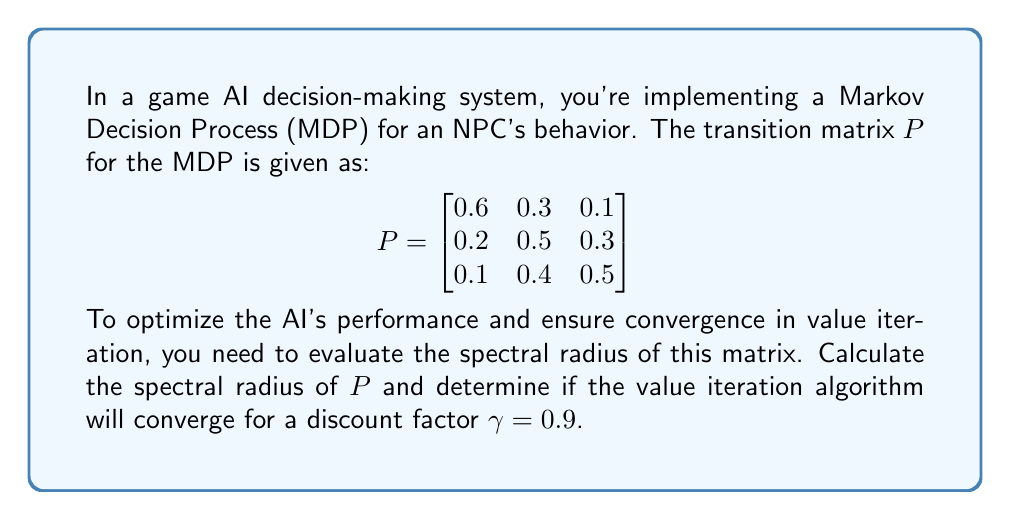Help me with this question. To solve this problem, we'll follow these steps:

1) The spectral radius of a matrix is the largest absolute value of its eigenvalues.

2) To find the eigenvalues, we need to solve the characteristic equation:
   $$\det(P - \lambda I) = 0$$

3) Expanding the determinant:
   $$\begin{vmatrix}
   0.6-\lambda & 0.3 & 0.1 \\
   0.2 & 0.5-\lambda & 0.3 \\
   0.1 & 0.4 & 0.5-\lambda
   \end{vmatrix} = 0$$

4) This gives us the characteristic polynomial:
   $$-\lambda^3 + 1.6\lambda^2 - 0.71\lambda + 0.088 = 0$$

5) Using a polynomial solver (as exact solutions are complex for cubic equations), we get the eigenvalues:
   $$\lambda_1 \approx 1, \lambda_2 \approx 0.4472, \lambda_3 \approx 0.1528$$

6) The spectral radius is the largest absolute value among these:
   $$\rho(P) = \max(|\lambda_1|, |\lambda_2|, |\lambda_3|) = 1$$

7) For value iteration to converge, we need $\gamma \rho(P) < 1$. Here:
   $$\gamma \rho(P) = 0.9 \cdot 1 = 0.9 < 1$$

Therefore, the value iteration algorithm will converge for $\gamma = 0.9$.
Answer: Spectral radius: 1. Value iteration converges for $\gamma = 0.9$. 